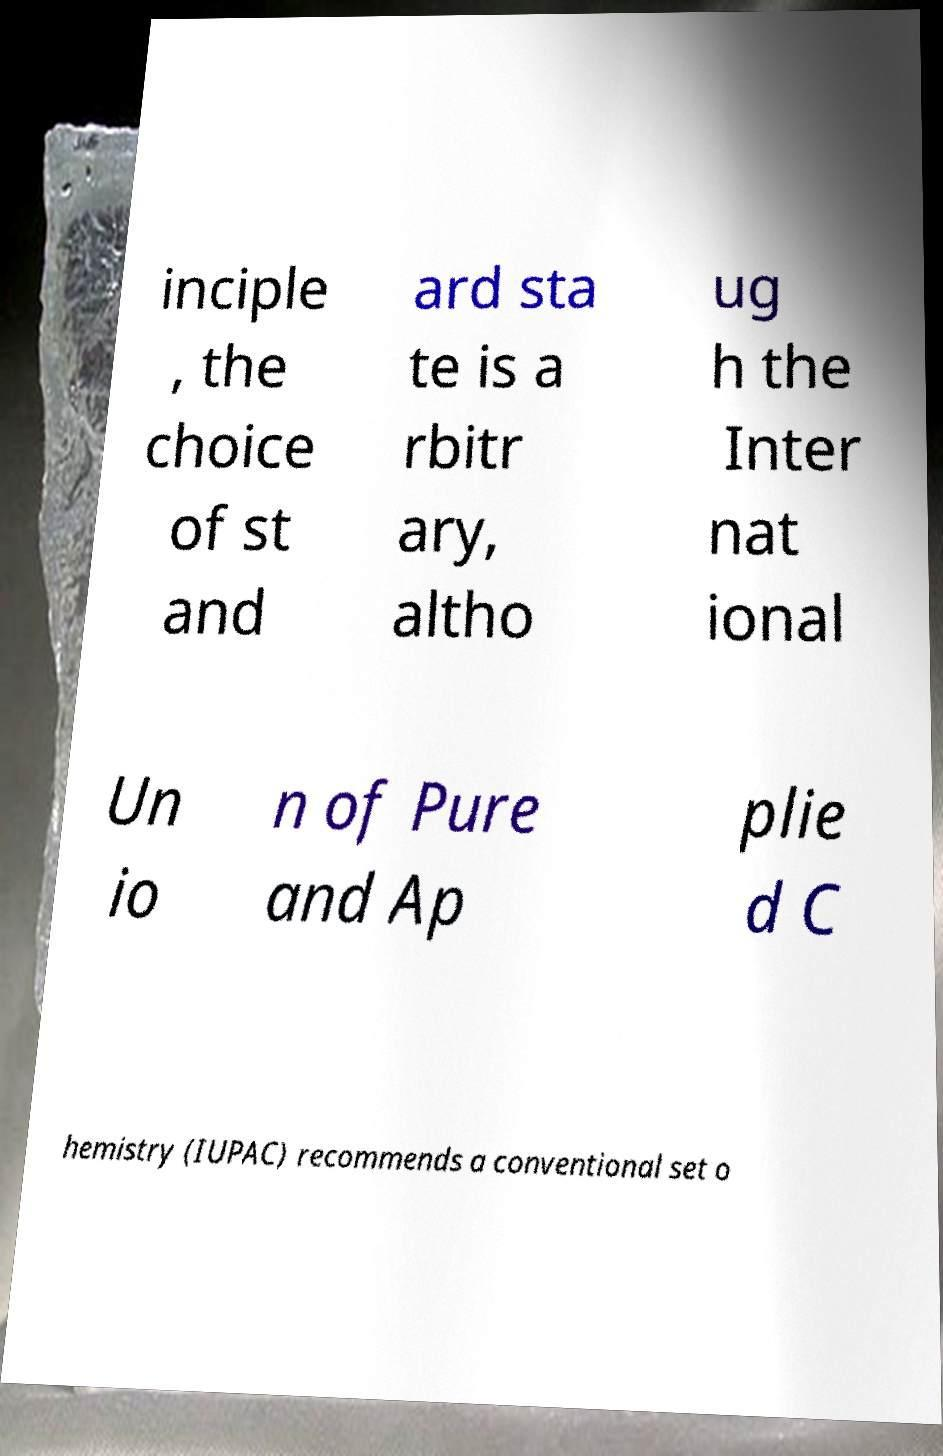Can you accurately transcribe the text from the provided image for me? inciple , the choice of st and ard sta te is a rbitr ary, altho ug h the Inter nat ional Un io n of Pure and Ap plie d C hemistry (IUPAC) recommends a conventional set o 